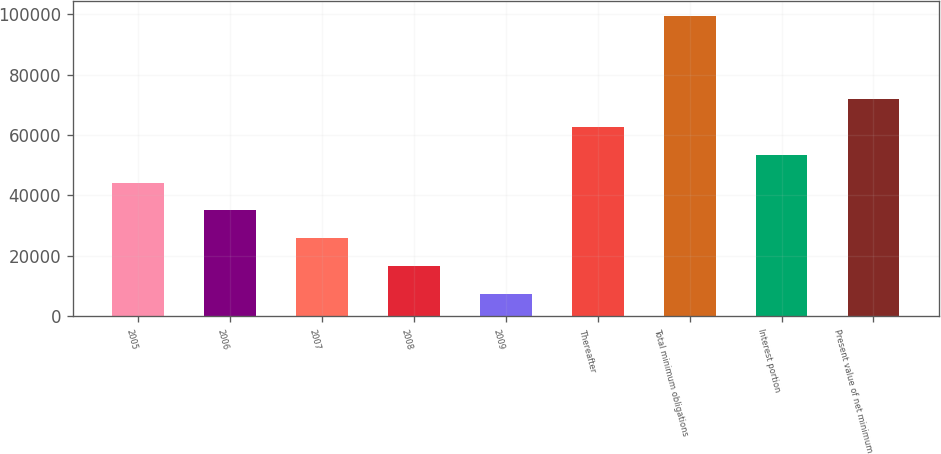<chart> <loc_0><loc_0><loc_500><loc_500><bar_chart><fcel>2005<fcel>2006<fcel>2007<fcel>2008<fcel>2009<fcel>Thereafter<fcel>Total minimum obligations<fcel>Interest portion<fcel>Present value of net minimum<nl><fcel>44210.4<fcel>34999.8<fcel>25789.2<fcel>16578.6<fcel>7368<fcel>62631.6<fcel>99474<fcel>53421<fcel>71842.2<nl></chart> 